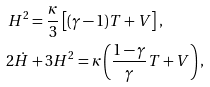<formula> <loc_0><loc_0><loc_500><loc_500>H ^ { 2 } & = \frac { \kappa } { 3 } \left [ ( \gamma - 1 ) T + V \right ] , \\ 2 \dot { H } & + 3 H ^ { 2 } = \kappa \left ( \frac { 1 - \gamma } { \gamma } T + V \right ) ,</formula> 